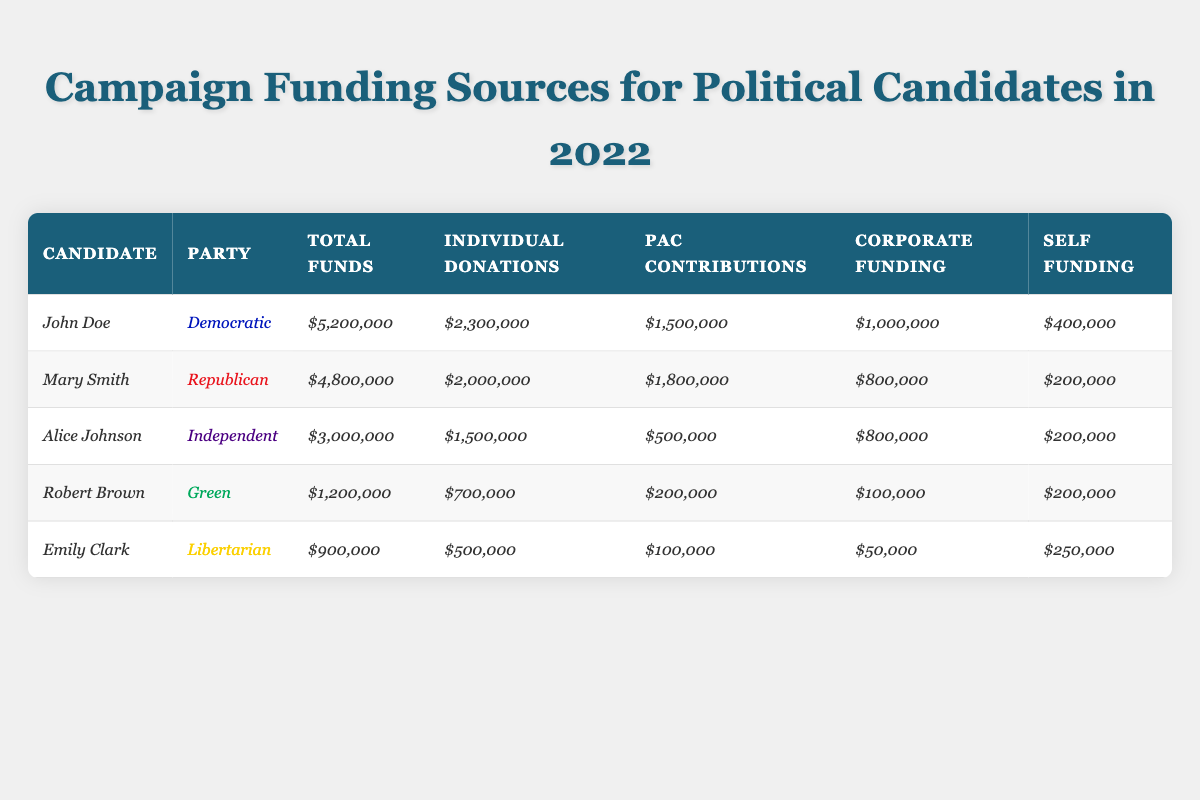What is the total funding amount for John Doe? According to the table, for John Doe, the "Total Funds" value is stated as $5,200,000.
Answer: $5,200,000 Which candidate received the highest amount of individual donations? By comparing the "Individual Donations" amounts for all candidates, John Doe received $2,300,000, which is higher than other candidates.
Answer: John Doe How much did Mary Smith receive from PAC contributions? In the table, the "PAC Contributions" for Mary Smith is shown as $1,800,000.
Answer: $1,800,000 Is it true that Alice Johnson received more corporate funding than Robert Brown? Checking the "Corporate Funding" amounts reveals that Alice Johnson received $800,000 while Robert Brown received $100,000, making the statement true.
Answer: Yes What is the difference in total funds raised between Mary Smith and Emily Clark? Mary Smith raised $4,800,000 and Emily Clark raised $900,000. The difference is $4,800,000 - $900,000 = $3,900,000.
Answer: $3,900,000 What is the total amount of self-funding by all candidates combined? Adding the "Self Funding" amounts together: $400,000 (John Doe) + $200,000 (Mary Smith) + $200,000 (Alice Johnson) + $200,000 (Robert Brown) + $250,000 (Emily Clark) gives a total of $1,250,000.
Answer: $1,250,000 Which party had the lowest total funding amount and what was it? Checking the total funds, the Green party (Robert Brown) had the lowest amount at $1,200,000.
Answer: Green party with $1,200,000 If we combine the individual donations of all candidates, what is the total? Summing the individual donations: $2,300,000 (John Doe) + $2,000,000 (Mary Smith) + $1,500,000 (Alice Johnson) + $700,000 (Robert Brown) + $500,000 (Emily Clark) results in $7,000,000.
Answer: $7,000,000 How much corporate funding did John Doe receive compared to the total funds? John Doe's corporate funding is $1,000,000 out of his total funds of $5,200,000, which is about 19.23% of the total funds.
Answer: 19.23% Which candidate had the least amount of total funds and what amount was it? The candidate with the least total funds is Emily Clark with $900,000.
Answer: Emily Clark with $900,000 